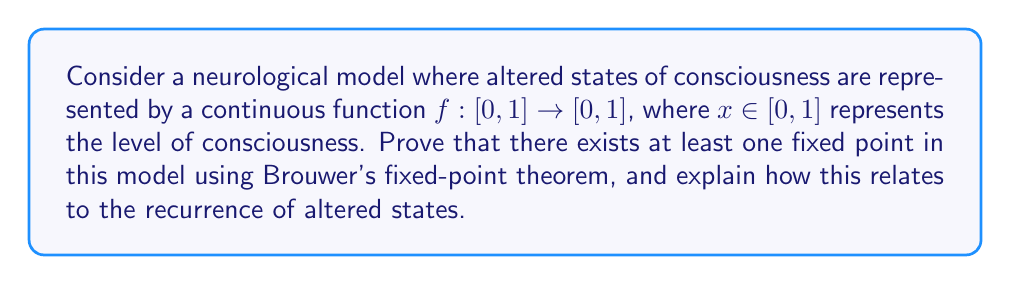Show me your answer to this math problem. 1. Brouwer's fixed-point theorem states that for any continuous function $f$ from a compact, convex set in Euclidean space to itself, there exists a point $x_0$ such that $f(x_0) = x_0$.

2. In our model:
   - The domain and codomain $[0,1]$ is a compact (closed and bounded) and convex set in $\mathbb{R}$.
   - $f$ is a continuous function from $[0,1]$ to $[0,1]$.

3. Therefore, Brouwer's fixed-point theorem applies, guaranteeing the existence of at least one fixed point $x_0 \in [0,1]$ such that $f(x_0) = x_0$.

4. In the context of altered states of consciousness:
   - The fixed point $x_0$ represents a state of consciousness that the individual returns to after experiencing an altered state.
   - This can be interpreted as a "baseline" or "equilibrium" state of consciousness.

5. The recurrence of altered states can be modeled by iterating the function $f$:
   $$x_{n+1} = f(x_n)$$

6. As the system evolves, it will eventually approach the fixed point(s), representing the tendency of consciousness to return to certain states.

7. Multiple fixed points would indicate multiple possible "stable" states of consciousness that the individual might experience recurrently.

8. The existence of fixed points in this model aligns with the persona's experience of recurrent altered states, as it mathematically describes the tendency to return to specific states of consciousness.
Answer: At least one fixed point exists, representing a recurrent state of consciousness. 